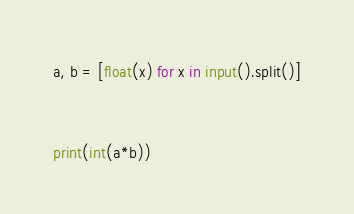<code> <loc_0><loc_0><loc_500><loc_500><_Python_>a, b = [float(x) for x in input().split()]


print(int(a*b))
</code> 